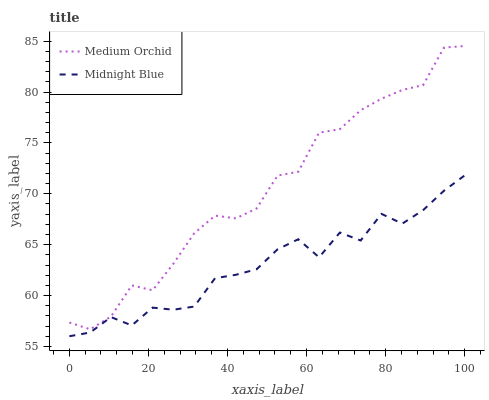Does Midnight Blue have the maximum area under the curve?
Answer yes or no. No. Is Midnight Blue the roughest?
Answer yes or no. No. Does Midnight Blue have the highest value?
Answer yes or no. No. Is Midnight Blue less than Medium Orchid?
Answer yes or no. Yes. Is Medium Orchid greater than Midnight Blue?
Answer yes or no. Yes. Does Midnight Blue intersect Medium Orchid?
Answer yes or no. No. 